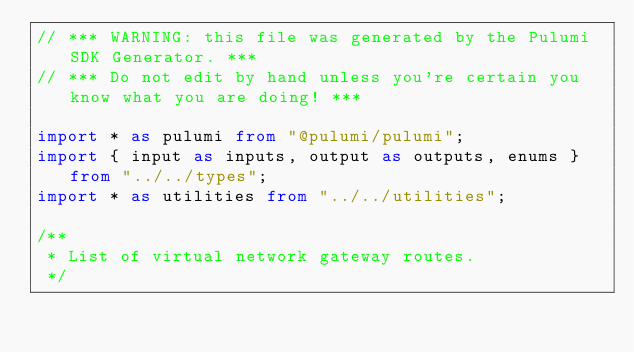<code> <loc_0><loc_0><loc_500><loc_500><_TypeScript_>// *** WARNING: this file was generated by the Pulumi SDK Generator. ***
// *** Do not edit by hand unless you're certain you know what you are doing! ***

import * as pulumi from "@pulumi/pulumi";
import { input as inputs, output as outputs, enums } from "../../types";
import * as utilities from "../../utilities";

/**
 * List of virtual network gateway routes.
 */</code> 